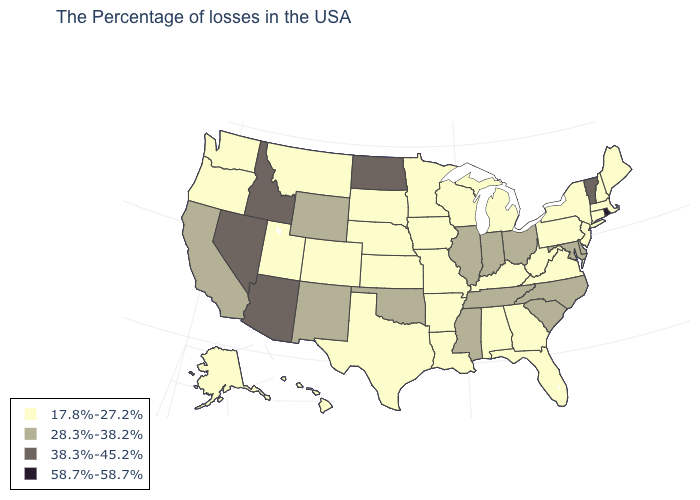Does West Virginia have the lowest value in the South?
Concise answer only. Yes. How many symbols are there in the legend?
Keep it brief. 4. Which states hav the highest value in the South?
Concise answer only. Delaware, Maryland, North Carolina, South Carolina, Tennessee, Mississippi, Oklahoma. Does the first symbol in the legend represent the smallest category?
Short answer required. Yes. What is the value of Kansas?
Concise answer only. 17.8%-27.2%. What is the value of South Carolina?
Keep it brief. 28.3%-38.2%. What is the value of West Virginia?
Write a very short answer. 17.8%-27.2%. What is the highest value in states that border New York?
Concise answer only. 38.3%-45.2%. What is the value of West Virginia?
Keep it brief. 17.8%-27.2%. What is the highest value in the USA?
Be succinct. 58.7%-58.7%. What is the value of Arkansas?
Quick response, please. 17.8%-27.2%. What is the highest value in the South ?
Answer briefly. 28.3%-38.2%. Name the states that have a value in the range 38.3%-45.2%?
Short answer required. Vermont, North Dakota, Arizona, Idaho, Nevada. Does Idaho have a higher value than Arizona?
Write a very short answer. No. Does Louisiana have a higher value than Hawaii?
Write a very short answer. No. 